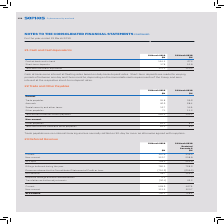According to Sophos Group's financial document, How does cash at bank earn interest? at floating rates based on daily bank deposit rates. The document states: "Cash at bank earns interest at floating rates based on daily bank deposit rates. Short-term deposits are made for varying periods of between one day a..." Also, What are short-term deposits made for? for varying periods of between one day and three months, depending on the immediate cash requirements of the Group, and earn interest at the respective short-term deposit rates.. The document states: "y bank deposit rates. Short-term deposits are made for varying periods of between one day and three months, depending on the immediate cash requiremen..." Also, What are the components making up the total cash and cash equivalents? The document shows two values: Cash at bank and in hand and Short-term deposits. From the document: "Cash at bank and in hand 134.3 67.2 Short-term deposits 37.8 52.8..." Additionally, In which year was the amount of short-term deposits larger? According to the financial document, 2018. The relevant text states: "31 March 2019 $M 31 March 2018 $M..." Also, can you calculate: What was the change in the Total cash and cash equivalent in 2019 from 2018? Based on the calculation: 172.1-120.0, the result is 52.1 (in millions). This is based on the information: "Total cash and cash equivalent 172.1 120.0 Total cash and cash equivalent 172.1 120.0..." The key data points involved are: 120.0, 172.1. Also, can you calculate: What was the percentage change in the Total cash and cash equivalent in 2019 from 2018? To answer this question, I need to perform calculations using the financial data. The calculation is: (172.1-120.0)/120.0, which equals 43.42 (percentage). This is based on the information: "Total cash and cash equivalent 172.1 120.0 Total cash and cash equivalent 172.1 120.0..." The key data points involved are: 120.0, 172.1. 